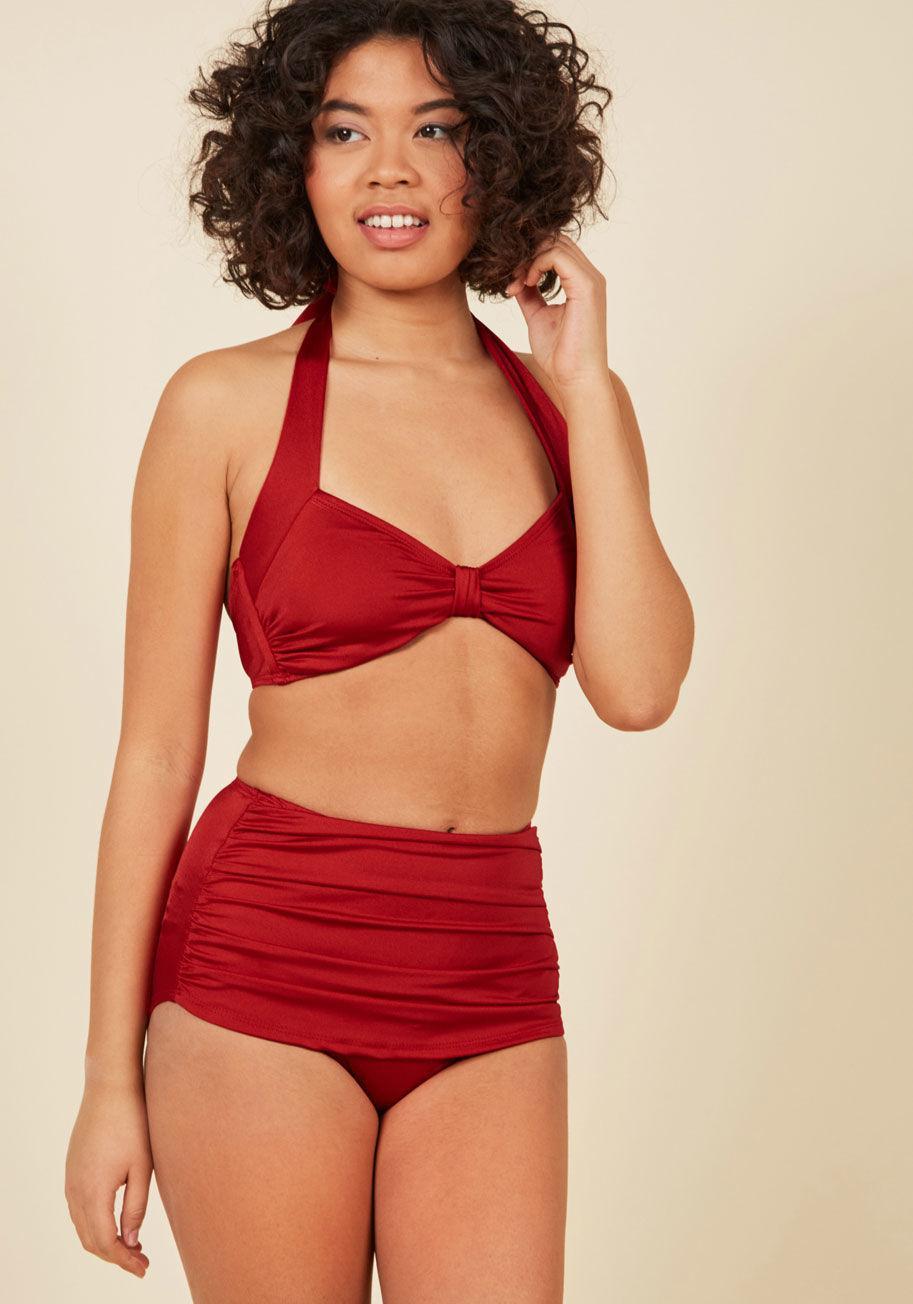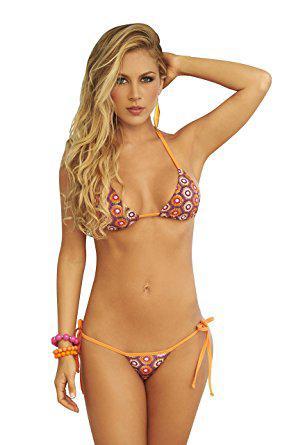The first image is the image on the left, the second image is the image on the right. Given the left and right images, does the statement "There is one red bikini" hold true? Answer yes or no. Yes. The first image is the image on the left, the second image is the image on the right. For the images shown, is this caption "At least one image shows a model wearing a high-waisted bikini bottom that just reaches the navel." true? Answer yes or no. Yes. 